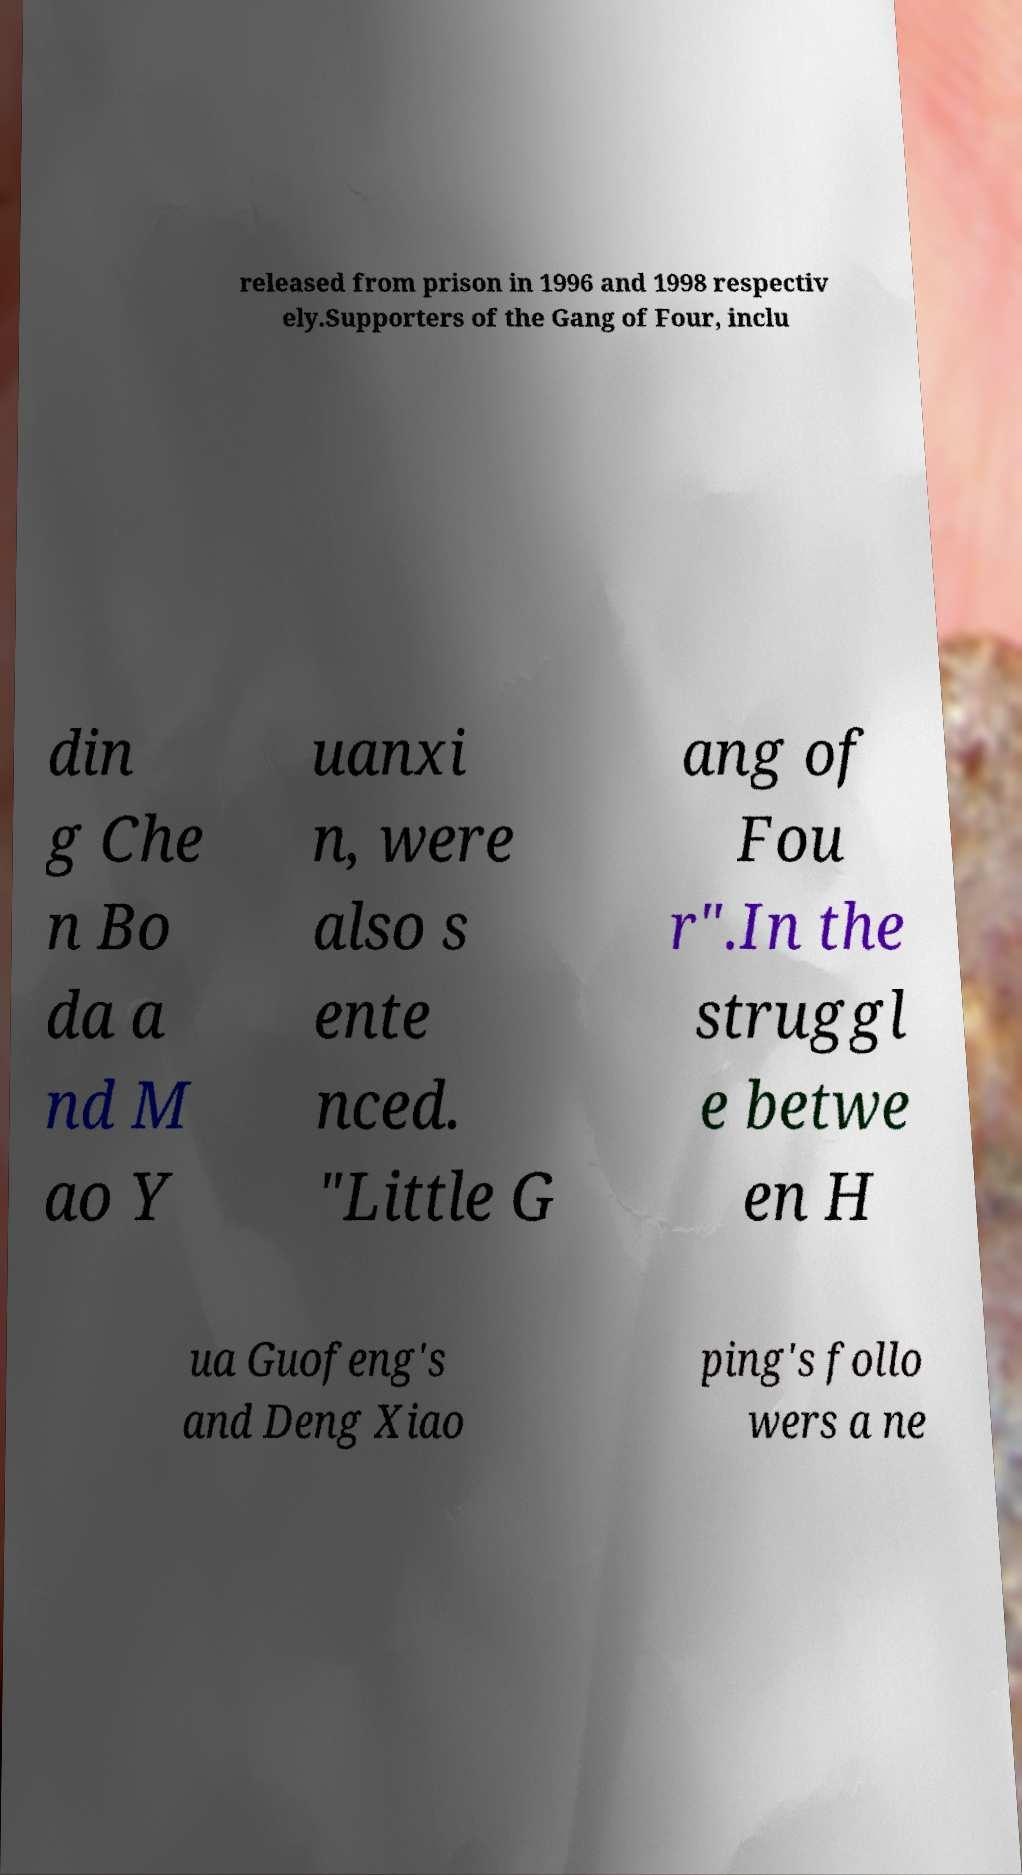Please read and relay the text visible in this image. What does it say? released from prison in 1996 and 1998 respectiv ely.Supporters of the Gang of Four, inclu din g Che n Bo da a nd M ao Y uanxi n, were also s ente nced. "Little G ang of Fou r".In the struggl e betwe en H ua Guofeng's and Deng Xiao ping's follo wers a ne 